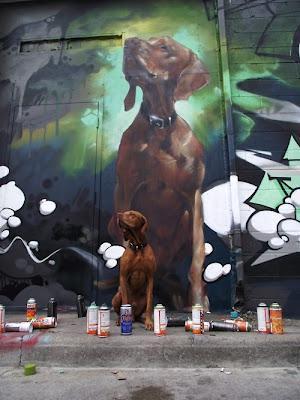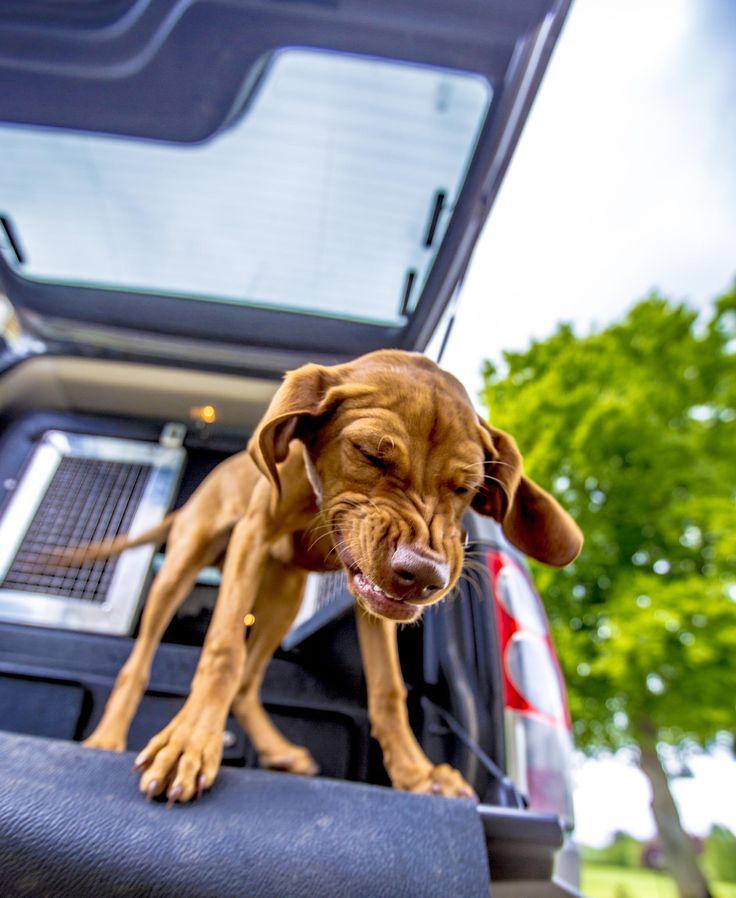The first image is the image on the left, the second image is the image on the right. Assess this claim about the two images: "One image shows a single dog, which has short reddish-orange fur and is standing on an elevated platform with its body turned forward.". Correct or not? Answer yes or no. Yes. The first image is the image on the left, the second image is the image on the right. Assess this claim about the two images: "There are exactly two live dogs.". Correct or not? Answer yes or no. Yes. 